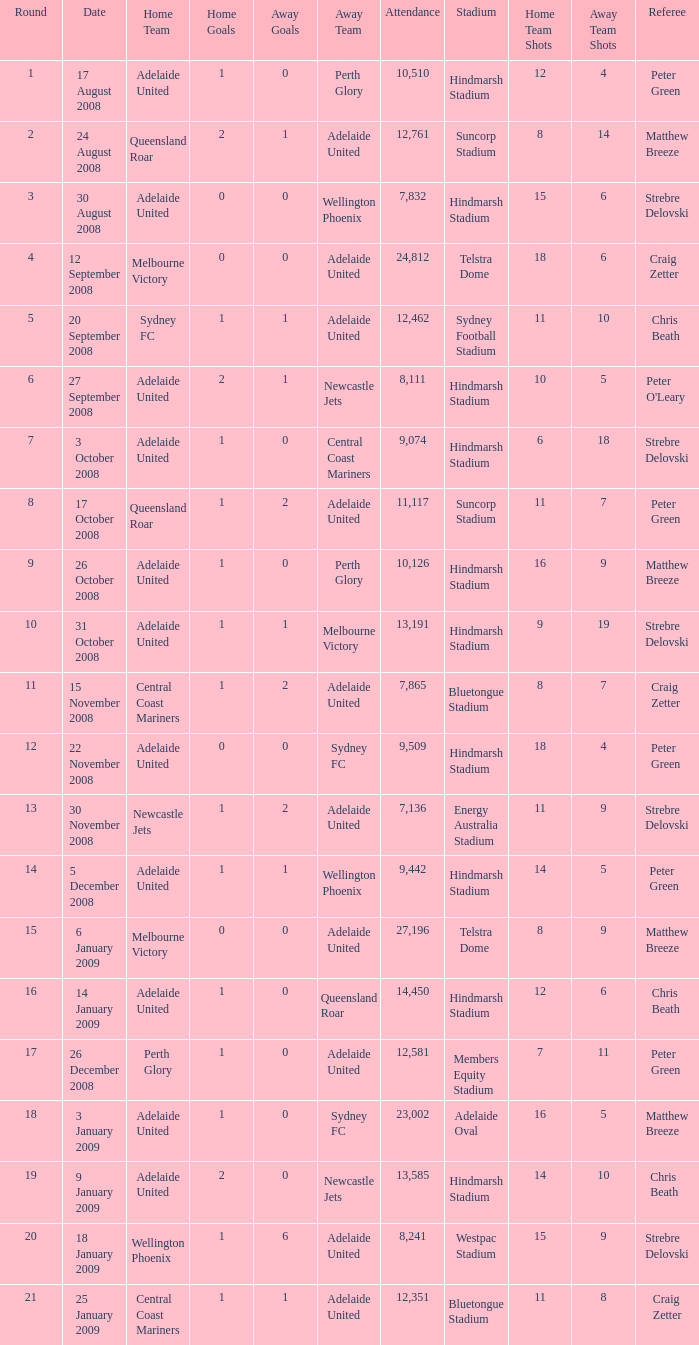Who was the away team when Queensland Roar was the home team in the round less than 3? Adelaide United. 